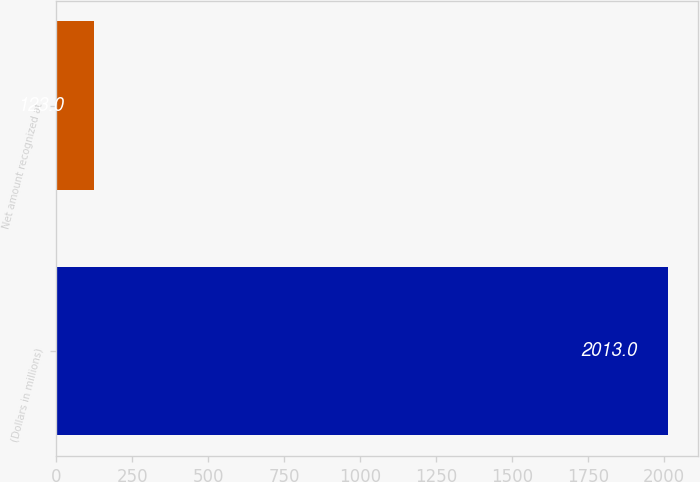Convert chart. <chart><loc_0><loc_0><loc_500><loc_500><bar_chart><fcel>(Dollars in millions)<fcel>Net amount recognized at<nl><fcel>2013<fcel>123<nl></chart> 